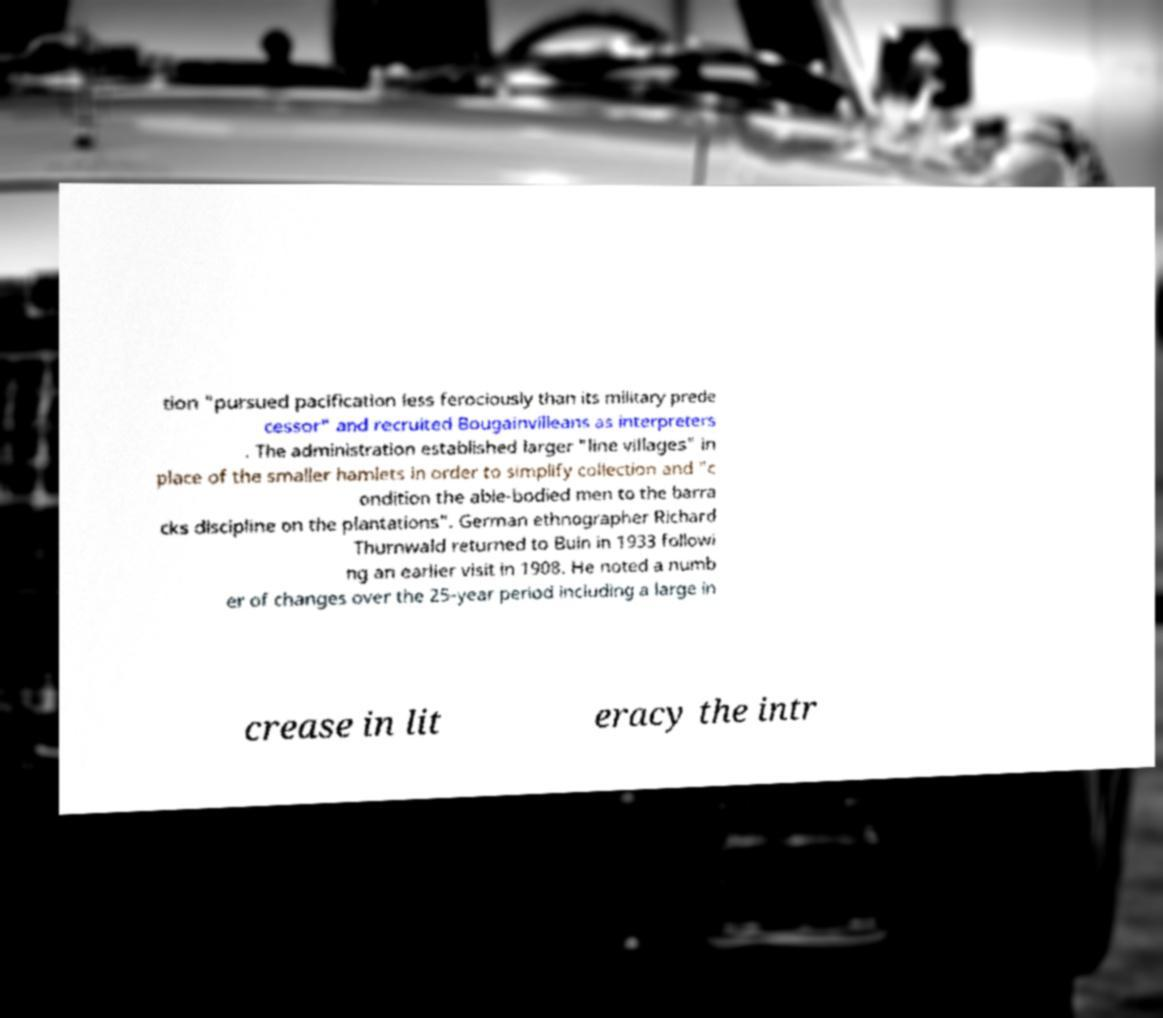What messages or text are displayed in this image? I need them in a readable, typed format. tion "pursued pacification less ferociously than its military prede cessor" and recruited Bougainvilleans as interpreters . The administration established larger "line villages" in place of the smaller hamlets in order to simplify collection and "c ondition the able-bodied men to the barra cks discipline on the plantations". German ethnographer Richard Thurnwald returned to Buin in 1933 followi ng an earlier visit in 1908. He noted a numb er of changes over the 25-year period including a large in crease in lit eracy the intr 